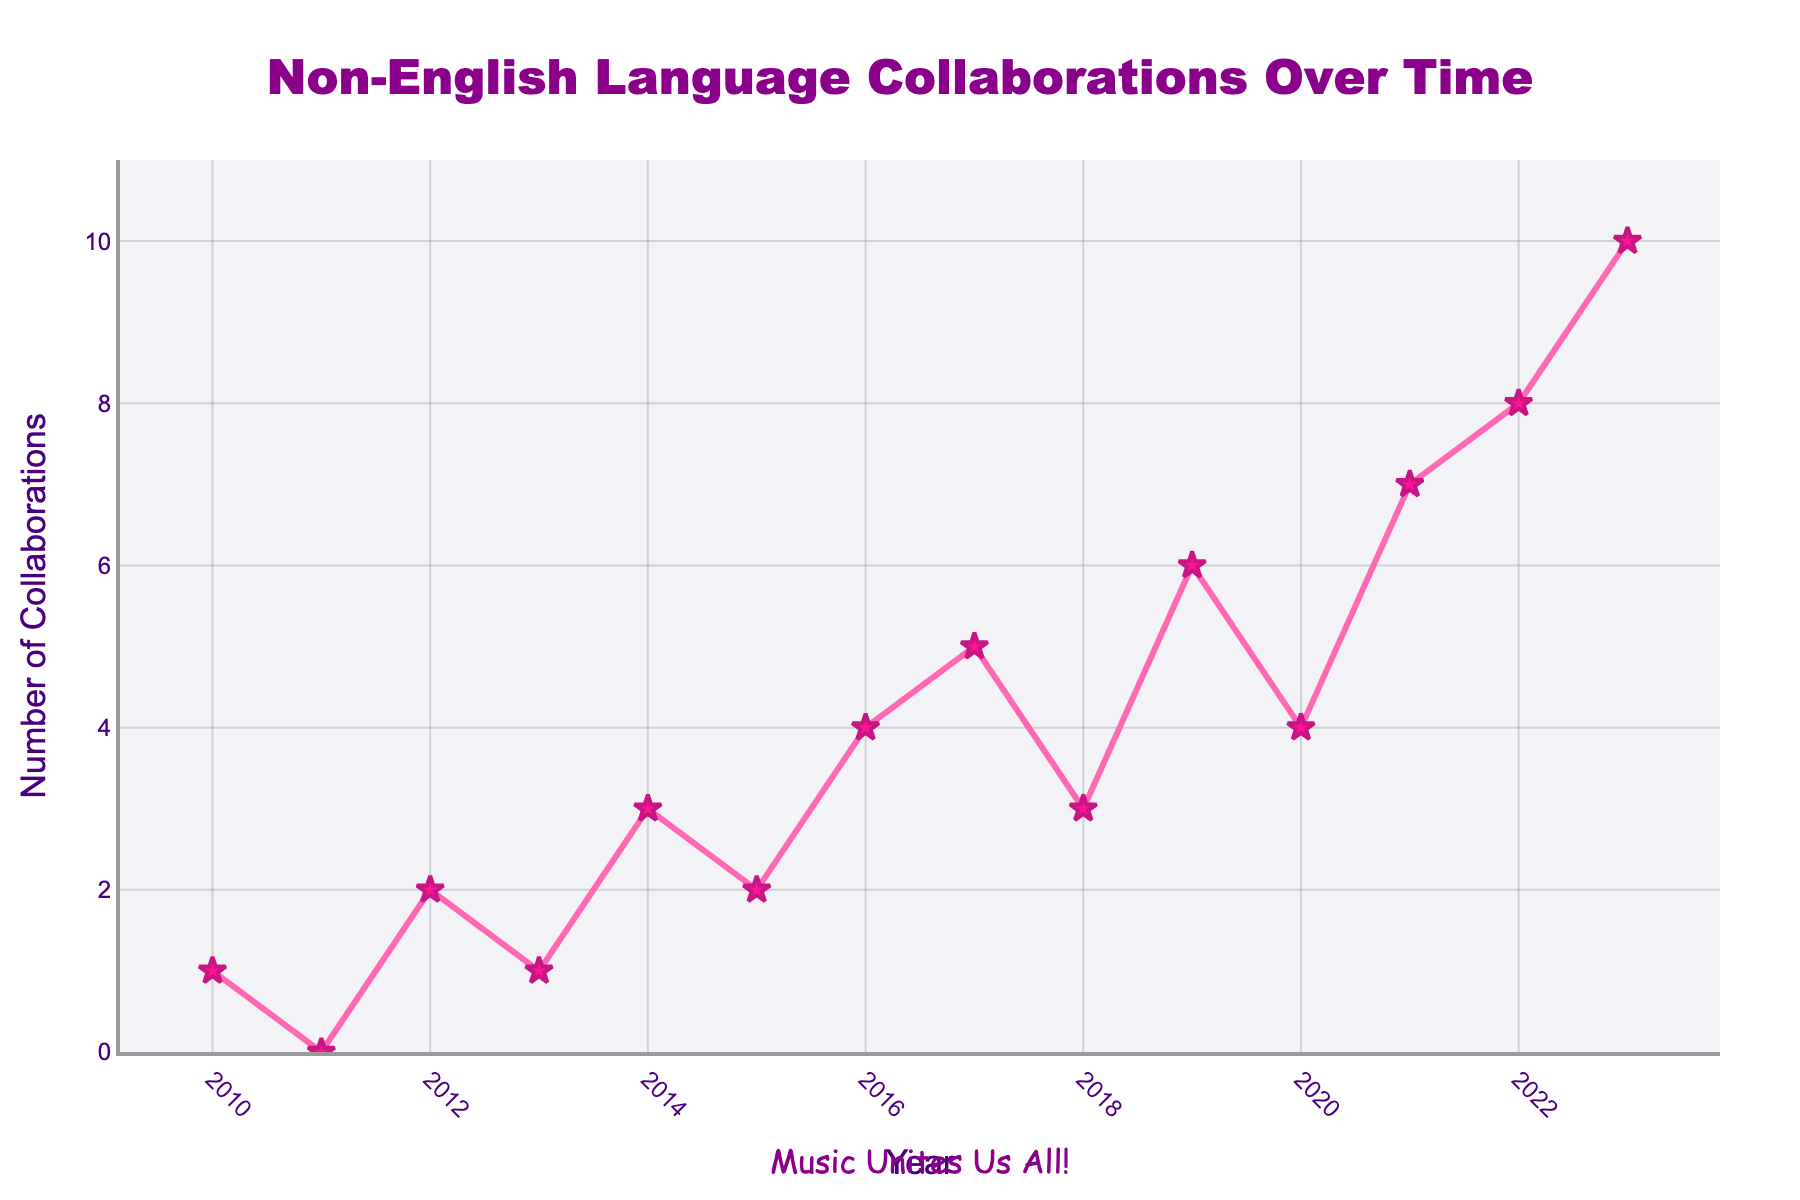What's the highest number of non-English collaborations in a year? To find the highest number of collaborations, we need to identify the maximum value on the y-axis. The data shows the highest value is 10 collaborations.
Answer: 10 Which year had the lowest number of non-English collaborations? To find the lowest number of collaborations, we look for the minimum value on the y-axis. The lowest value is 0 in 2011.
Answer: 2011 How many collaborations were there from 2010 to 2013? To find the total collaborations, we sum the values for the years 2010-2013. The values are 1, 0, 2, and 1 respectively. So, 1 + 0 + 2 + 1 = 4.
Answer: 4 What's the average number of collaborations over the entire period? To calculate the average, we sum the total number of collaborations and divide by the number of years (14 years). Total collaborations are 56. So, 56/14 = 4.
Answer: 4 In which year did the collaborations increase the most from the previous year? To find the largest increase, compare the differences between consecutive years. The increase from 2022 (8) to 2023 (10) is 2, which is the largest increase.
Answer: 2023 What's the difference in collaborations between 2017 and 2019? To find the difference, subtract the number for 2017 (5) from the number for 2019 (6). 6 - 5 = 1.
Answer: 1 Which years had collaborations greater than or equal to 5? To find years with collaborations ≥ 5, we identify years with values 5 or more. These years are 2017, 2019, 2021, 2022, and 2023.
Answer: 2017, 2019, 2021, 2022, 2023 What's the trend of collaborations from 2018 to 2020? To identify the trend, observe the values for the years 2018, 2019, and 2020. They go from 3 to 6 to 4, which shows an initial increase followed by a decrease.
Answer: Increase then decrease What's the median number of collaborations over the years? To find the median, we need to sort the values and identify the middle one. For 14 years, the median is the average of the 7th and 8th values in the sorted list, which are 3 and 4. So, (3 + 4) / 2 = 3.5.
Answer: 3.5 